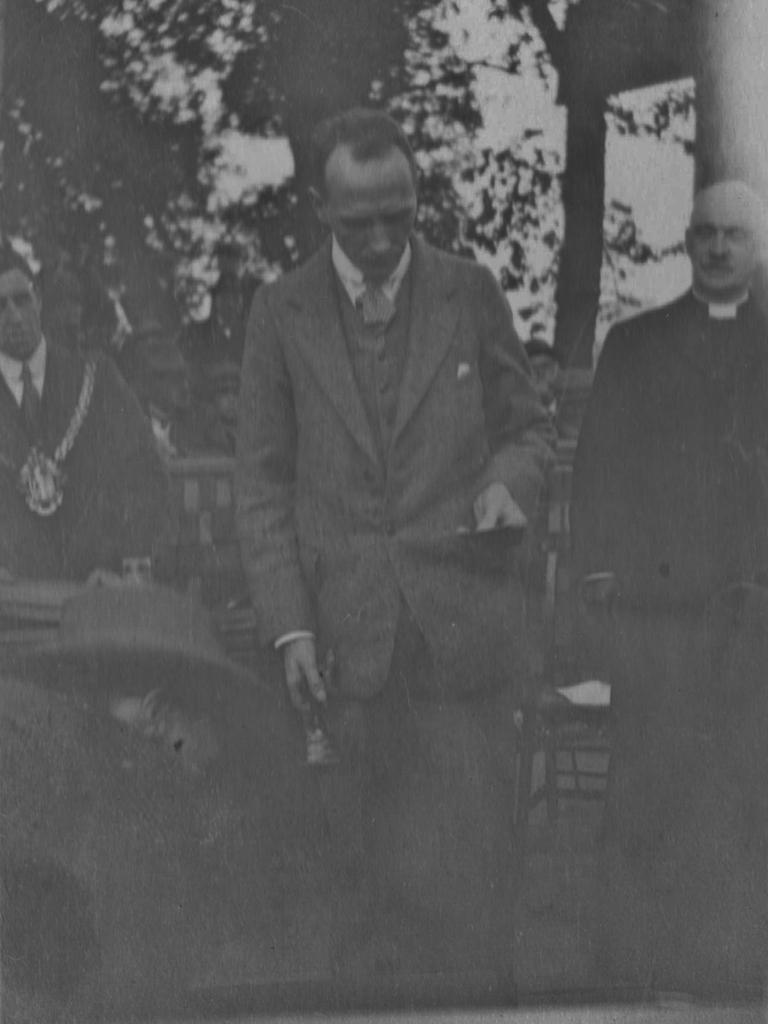What is happening in the image? There are persons standing in the image. How are the persons dressed? The persons are wearing different dress. What can be seen in the background of the image? There is a truss and a building visible in the image. What is the color scheme of the image? The image is in black and white. Can you tell me how many horses are present in the image? There are no horses present in the image. What order are the persons standing in? The image does not indicate any specific order in which the persons are standing. 